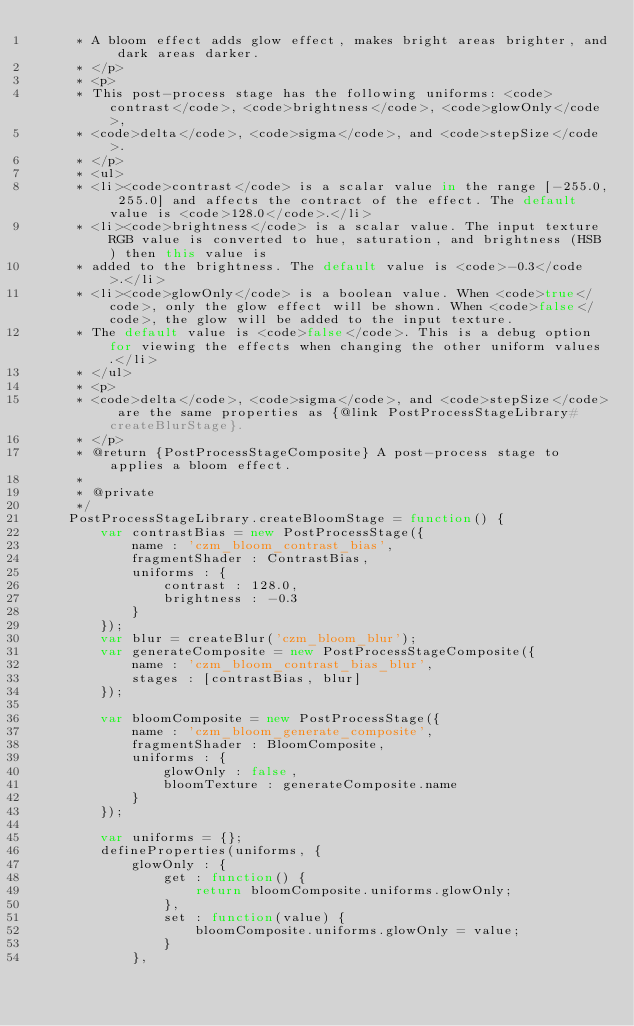Convert code to text. <code><loc_0><loc_0><loc_500><loc_500><_JavaScript_>     * A bloom effect adds glow effect, makes bright areas brighter, and dark areas darker.
     * </p>
     * <p>
     * This post-process stage has the following uniforms: <code>contrast</code>, <code>brightness</code>, <code>glowOnly</code>,
     * <code>delta</code>, <code>sigma</code>, and <code>stepSize</code>.
     * </p>
     * <ul>
     * <li><code>contrast</code> is a scalar value in the range [-255.0, 255.0] and affects the contract of the effect. The default value is <code>128.0</code>.</li>
     * <li><code>brightness</code> is a scalar value. The input texture RGB value is converted to hue, saturation, and brightness (HSB) then this value is
     * added to the brightness. The default value is <code>-0.3</code>.</li>
     * <li><code>glowOnly</code> is a boolean value. When <code>true</code>, only the glow effect will be shown. When <code>false</code>, the glow will be added to the input texture.
     * The default value is <code>false</code>. This is a debug option for viewing the effects when changing the other uniform values.</li>
     * </ul>
     * <p>
     * <code>delta</code>, <code>sigma</code>, and <code>stepSize</code> are the same properties as {@link PostProcessStageLibrary#createBlurStage}.
     * </p>
     * @return {PostProcessStageComposite} A post-process stage to applies a bloom effect.
     *
     * @private
     */
    PostProcessStageLibrary.createBloomStage = function() {
        var contrastBias = new PostProcessStage({
            name : 'czm_bloom_contrast_bias',
            fragmentShader : ContrastBias,
            uniforms : {
                contrast : 128.0,
                brightness : -0.3
            }
        });
        var blur = createBlur('czm_bloom_blur');
        var generateComposite = new PostProcessStageComposite({
            name : 'czm_bloom_contrast_bias_blur',
            stages : [contrastBias, blur]
        });

        var bloomComposite = new PostProcessStage({
            name : 'czm_bloom_generate_composite',
            fragmentShader : BloomComposite,
            uniforms : {
                glowOnly : false,
                bloomTexture : generateComposite.name
            }
        });

        var uniforms = {};
        defineProperties(uniforms, {
            glowOnly : {
                get : function() {
                    return bloomComposite.uniforms.glowOnly;
                },
                set : function(value) {
                    bloomComposite.uniforms.glowOnly = value;
                }
            },</code> 